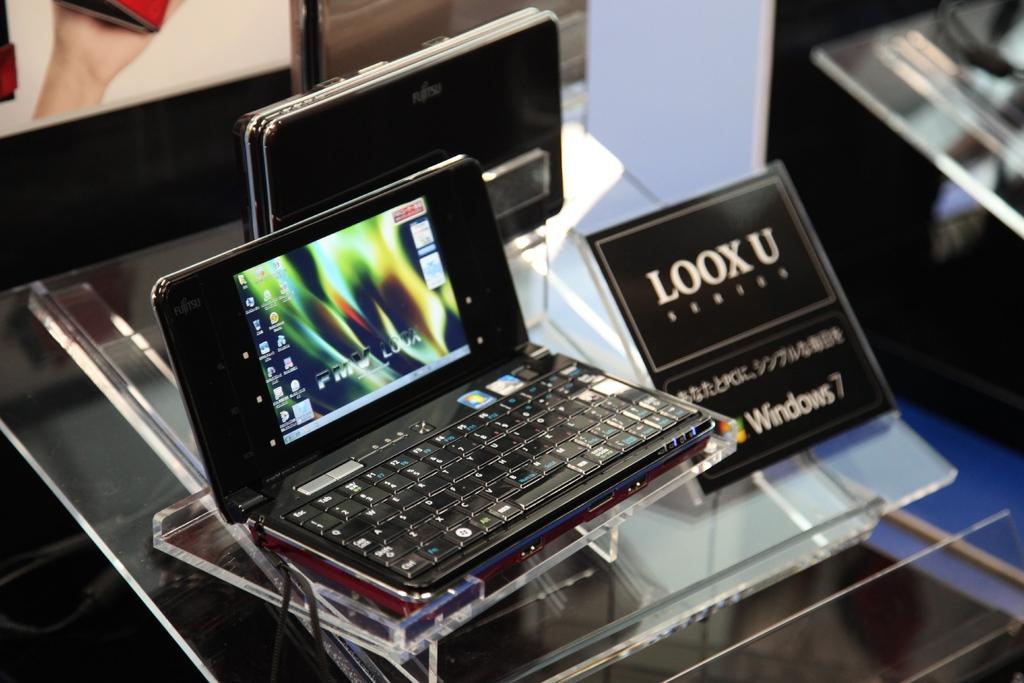What operation system is used by this device?
Provide a short and direct response. Windows 7. What is being displayed?
Ensure brevity in your answer.  Loox u. 